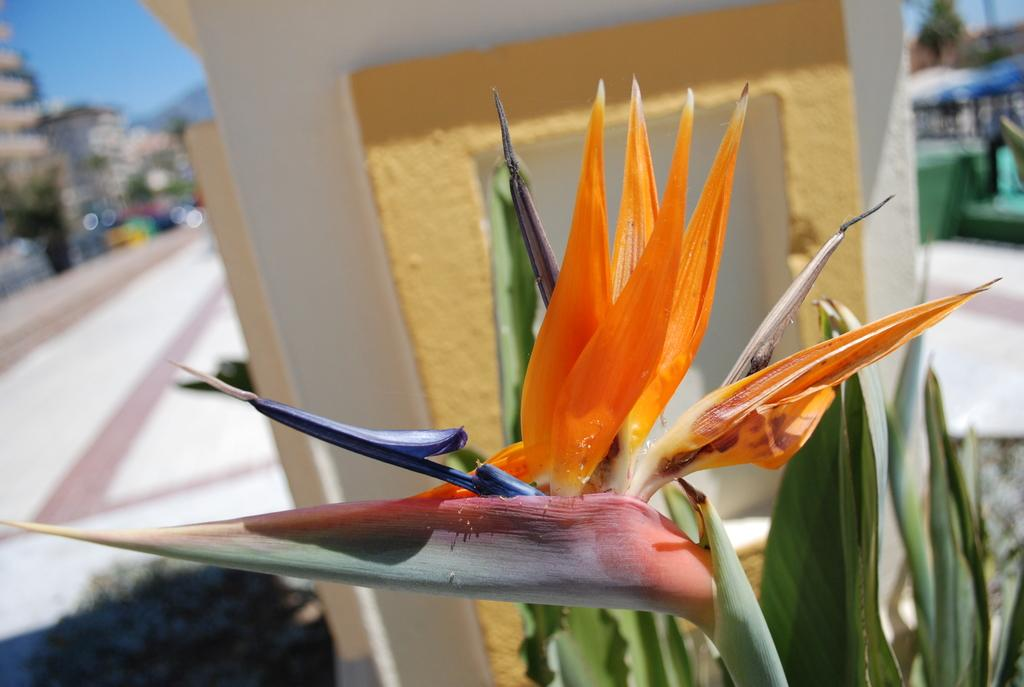What type of plant is visible in the image? There is a plant with a flower in the image. What architectural feature can be seen in the image? There is a pillar in the image. How would you describe the background of the image? The background appears blurry. What list or record is being kept on the plant in the image? There is no list or record present in the image; it features a plant with a flower and a pillar. What month is it in the image? The image does not provide any information about the month or time of year. 